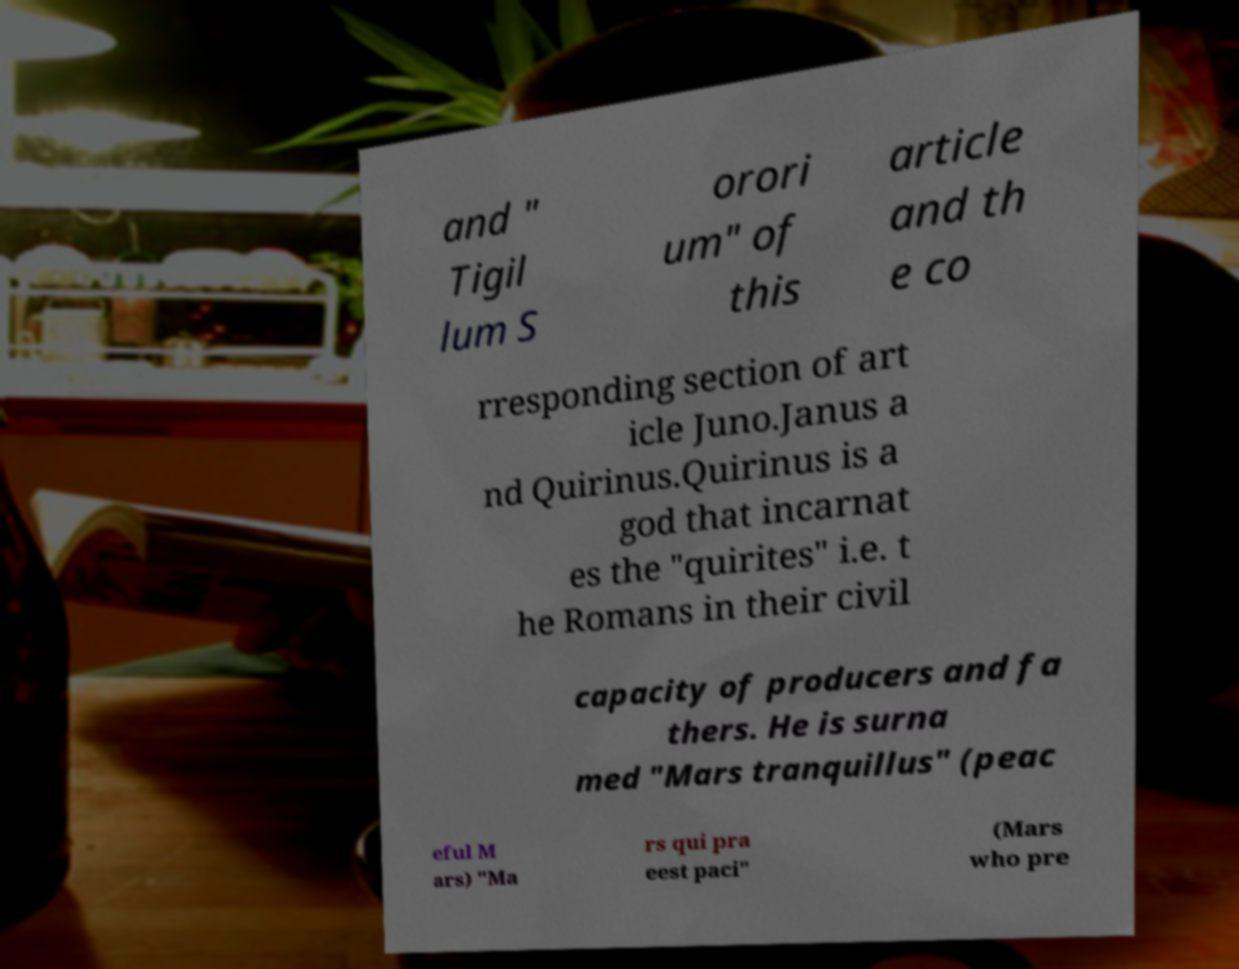Can you read and provide the text displayed in the image?This photo seems to have some interesting text. Can you extract and type it out for me? and " Tigil lum S orori um" of this article and th e co rresponding section of art icle Juno.Janus a nd Quirinus.Quirinus is a god that incarnat es the "quirites" i.e. t he Romans in their civil capacity of producers and fa thers. He is surna med "Mars tranquillus" (peac eful M ars) "Ma rs qui pra eest paci" (Mars who pre 